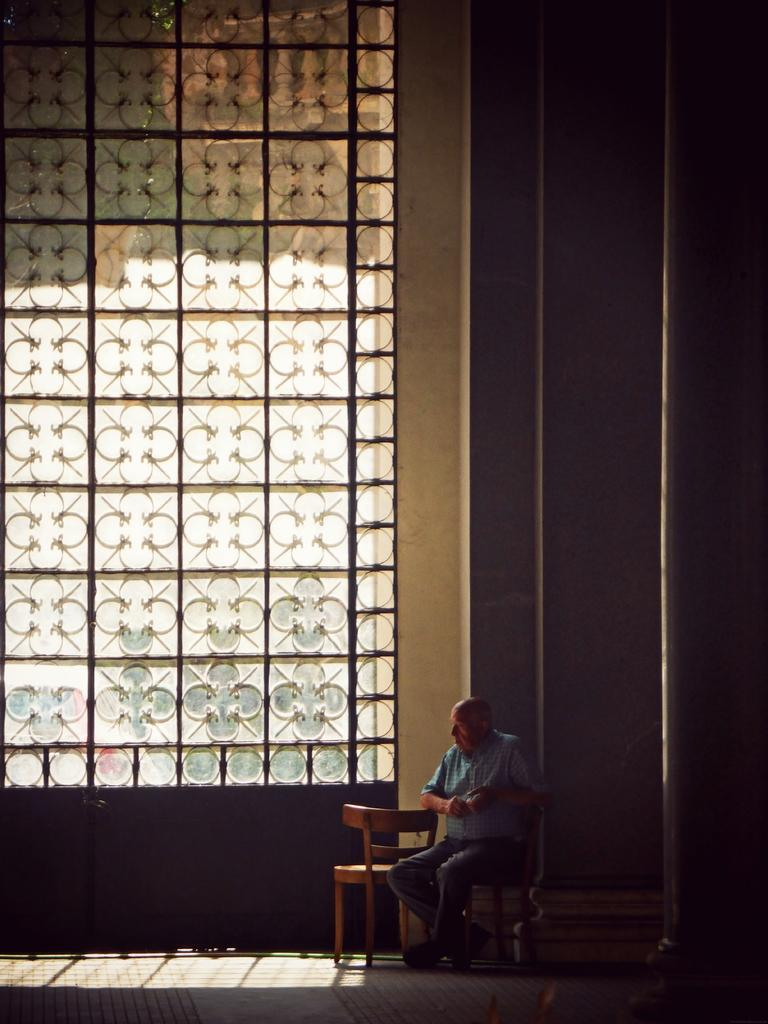What is the person in the image doing? The person is sitting on a chair in the image. What can be seen behind the person? There is a big glass window in the image. What type of pancake is being used to support the chair in the image? There is no pancake present in the image, and the chair is not being supported by any pancake. 